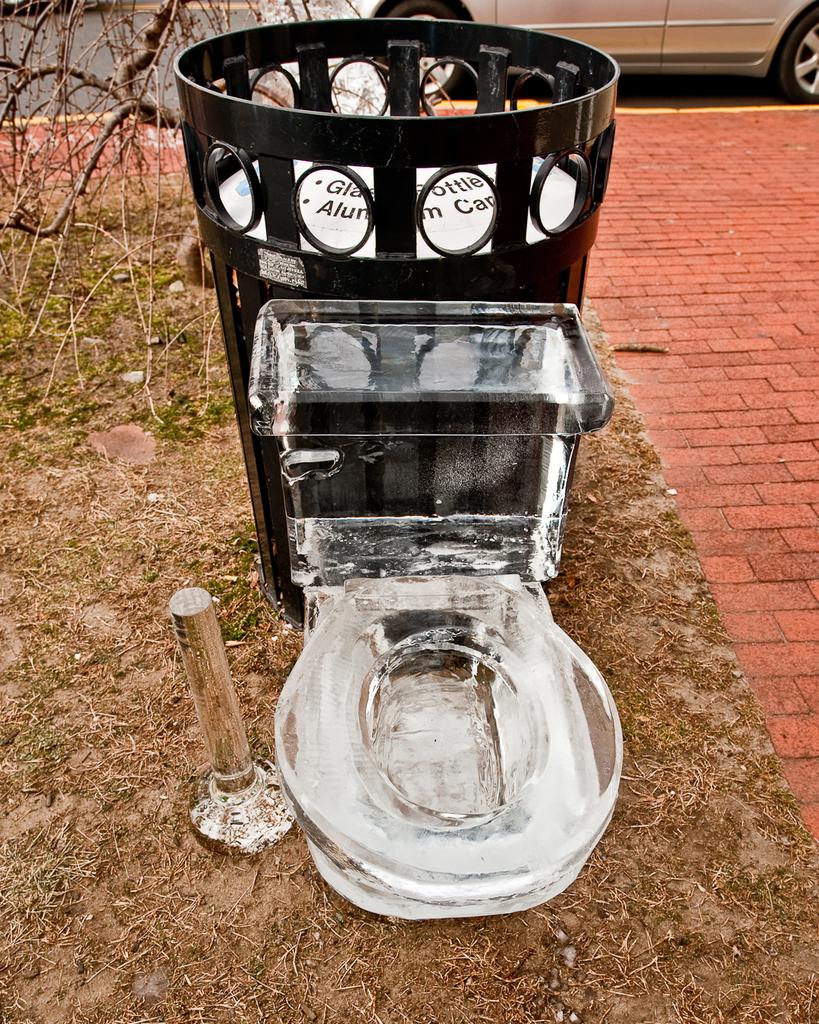Is that a trashcan in the back?
Provide a short and direct response. Answering does not require reading text in the image. 